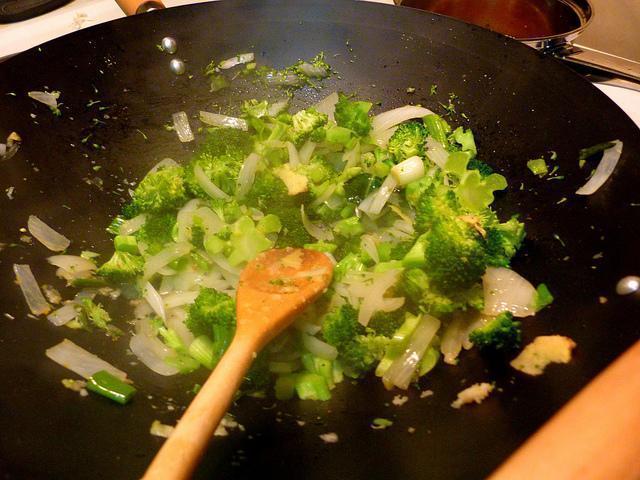What food type is in the pan?
Indicate the correct response by choosing from the four available options to answer the question.
Options: Fruit, meat, vegetables, candy. Vegetables. 